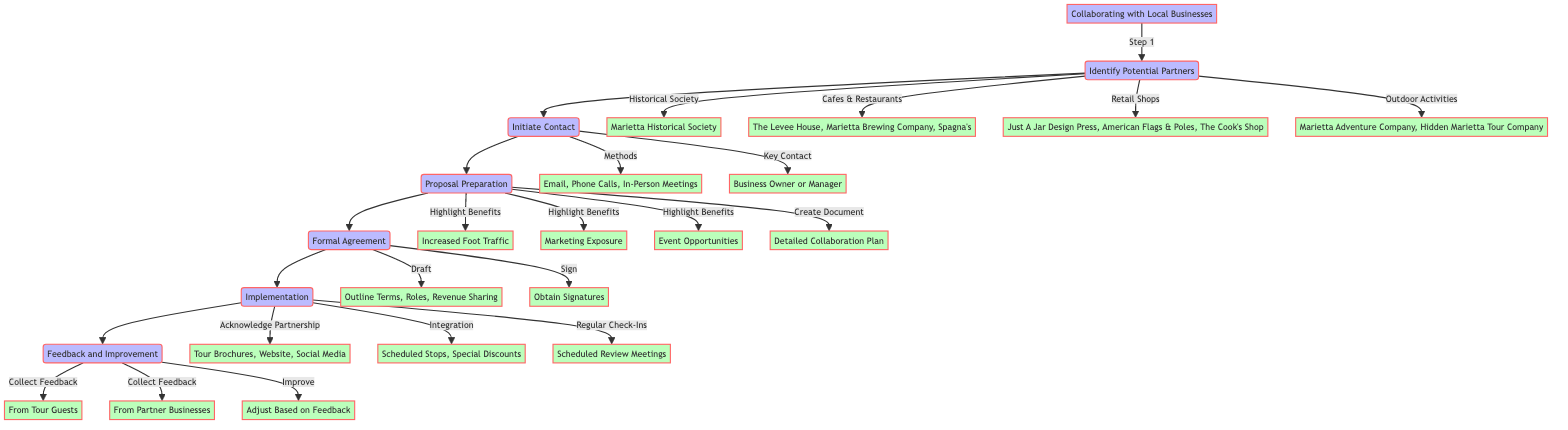What is the first step in collaborating with local businesses? The first step in the flow chart is "Identify Potential Partners," which initiates the process of collaboration by recognizing potential local businesses to work with.
Answer: Identify Potential Partners How many types of local businesses are identified as potential partners? In the diagram, four types of local businesses are identified: Local Historical Society, Local Cafes and Restaurants, Local Retail Shops, and Outdoor Activity Providers.
Answer: Four Who is the key contact person to initiate contact? According to the diagram, the key contact person to initiate contact with local businesses is the "Business Owner or Manager."
Answer: Business Owner or Manager What are the methods for initiating contact? The methods listed in the flowchart for initiating contact include Email, Phone Calls, and In-Person Meetings.
Answer: Email, Phone Calls, In-Person Meetings What are the highlighted mutual benefits in the proposal preparation step? The highlighted mutual benefits include Increased Foot Traffic, Marketing Exposure, and Event Opportunities as depicted in the proposal preparation section of the diagram.
Answer: Increased Foot Traffic, Marketing Exposure, Event Opportunities What is created to outline collaboration ideas? The diagram states that a "Detailed Collaboration Plan" is created to outline collaboration ideas, logistics, and benefits during the proposal preparation phase.
Answer: Detailed Collaboration Plan What is the purpose of the regular check-ins during implementation? The regular check-ins during the implementation step serve the purpose of holding "Scheduled Review Meetings" to discuss and optimize the collaborations.
Answer: Scheduled Review Meetings From whom is feedback collected? According to the feedback and improvement phase in the diagram, feedback is collected from Tour Guests and Partner Businesses.
Answer: From Tour Guests, From Partner Businesses What actions are taken after collecting feedback? The flowchart indicates that after collecting feedback, actions are taken to "Adjust Based on Feedback" to enhance collaboration continuously.
Answer: Adjust Based on Feedback 